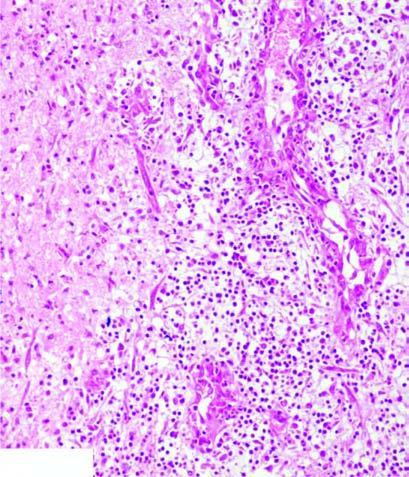what shows a cystic space containing cell debris, while the surrounding zone shows granulation tissue and gliosis?
Answer the question using a single word or phrase. Necrosed area right side of field esurrounding gliosis 